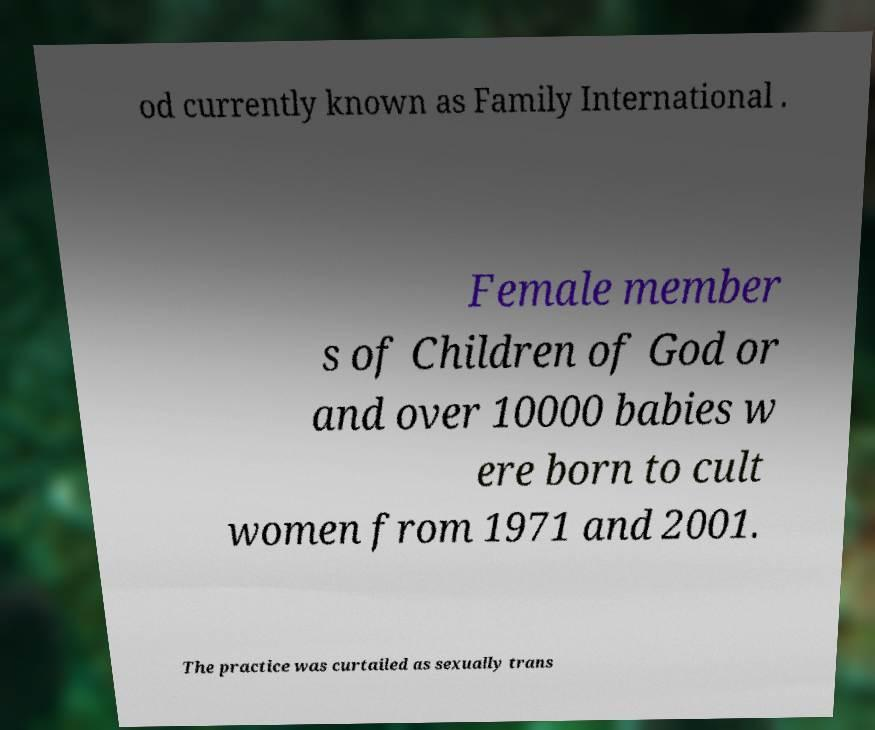I need the written content from this picture converted into text. Can you do that? od currently known as Family International . Female member s of Children of God or and over 10000 babies w ere born to cult women from 1971 and 2001. The practice was curtailed as sexually trans 